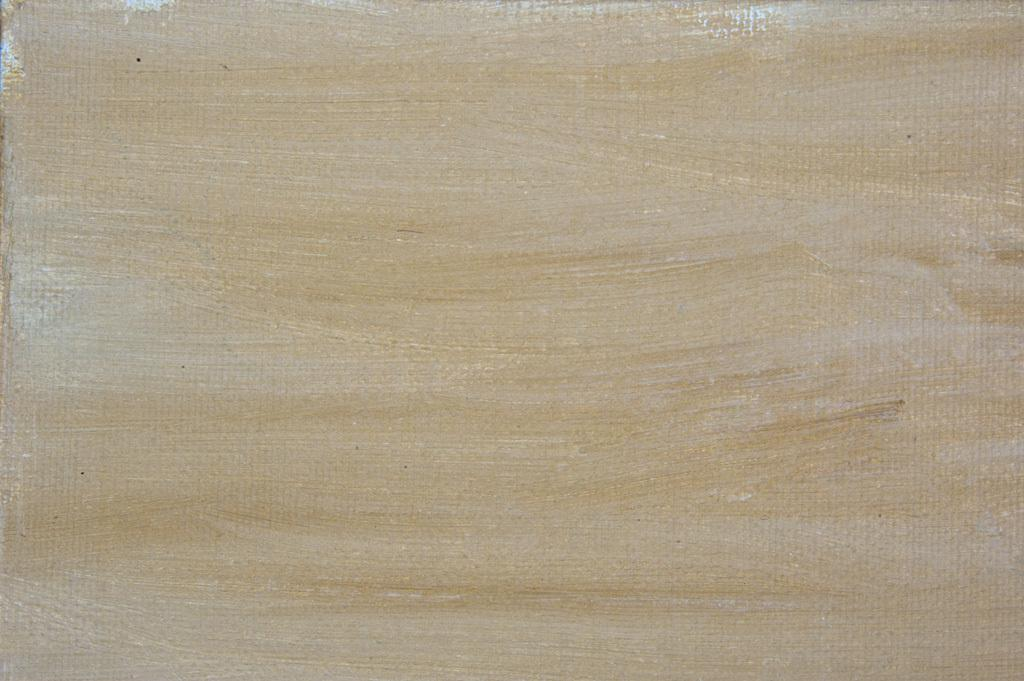What is the primary color of the surface in the image? The primary color of the surface in the image is cream. What can be observed on the surface? There are patches on the surface. What type of meat is being sold at the church in the image? There is no meat or church present in the image; it only features a cream-colored surface with patches. 